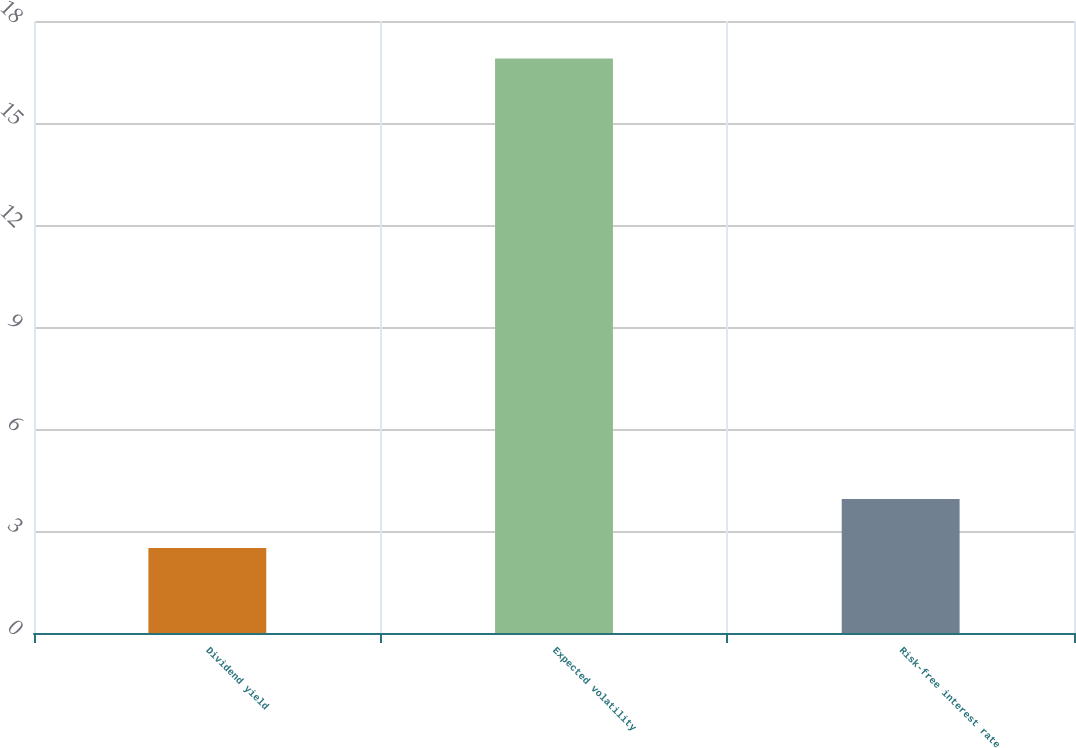Convert chart. <chart><loc_0><loc_0><loc_500><loc_500><bar_chart><fcel>Dividend yield<fcel>Expected volatility<fcel>Risk-free interest rate<nl><fcel>2.5<fcel>16.9<fcel>3.94<nl></chart> 